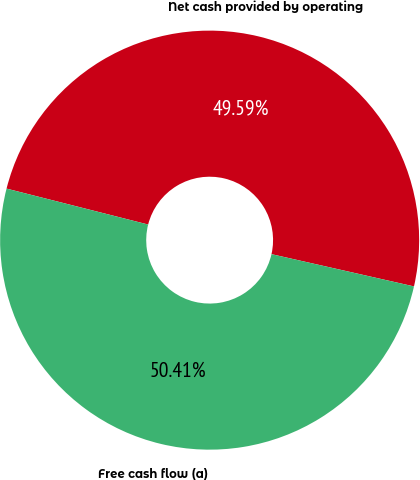<chart> <loc_0><loc_0><loc_500><loc_500><pie_chart><fcel>Net cash provided by operating<fcel>Free cash flow (a)<nl><fcel>49.59%<fcel>50.41%<nl></chart> 